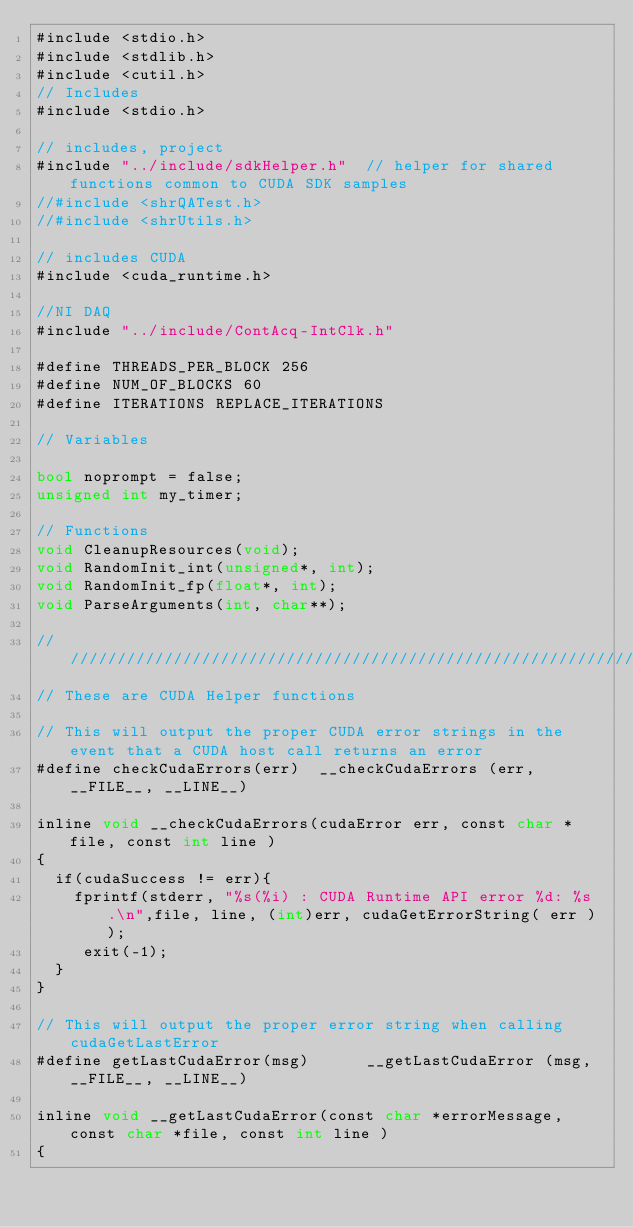Convert code to text. <code><loc_0><loc_0><loc_500><loc_500><_Cuda_>#include <stdio.h>
#include <stdlib.h>
#include <cutil.h>
// Includes
#include <stdio.h>

// includes, project
#include "../include/sdkHelper.h"  // helper for shared functions common to CUDA SDK samples
//#include <shrQATest.h>
//#include <shrUtils.h>

// includes CUDA
#include <cuda_runtime.h>

//NI DAQ
#include "../include/ContAcq-IntClk.h"

#define THREADS_PER_BLOCK 256
#define NUM_OF_BLOCKS 60
#define ITERATIONS REPLACE_ITERATIONS

// Variables

bool noprompt = false;
unsigned int my_timer;

// Functions
void CleanupResources(void);
void RandomInit_int(unsigned*, int);
void RandomInit_fp(float*, int);
void ParseArguments(int, char**);

////////////////////////////////////////////////////////////////////////////////
// These are CUDA Helper functions

// This will output the proper CUDA error strings in the event that a CUDA host call returns an error
#define checkCudaErrors(err)  __checkCudaErrors (err, __FILE__, __LINE__)

inline void __checkCudaErrors(cudaError err, const char *file, const int line )
{
  if(cudaSuccess != err){
	fprintf(stderr, "%s(%i) : CUDA Runtime API error %d: %s.\n",file, line, (int)err, cudaGetErrorString( err ) );
	 exit(-1);
  }
}

// This will output the proper error string when calling cudaGetLastError
#define getLastCudaError(msg)      __getLastCudaError (msg, __FILE__, __LINE__)

inline void __getLastCudaError(const char *errorMessage, const char *file, const int line )
{</code> 